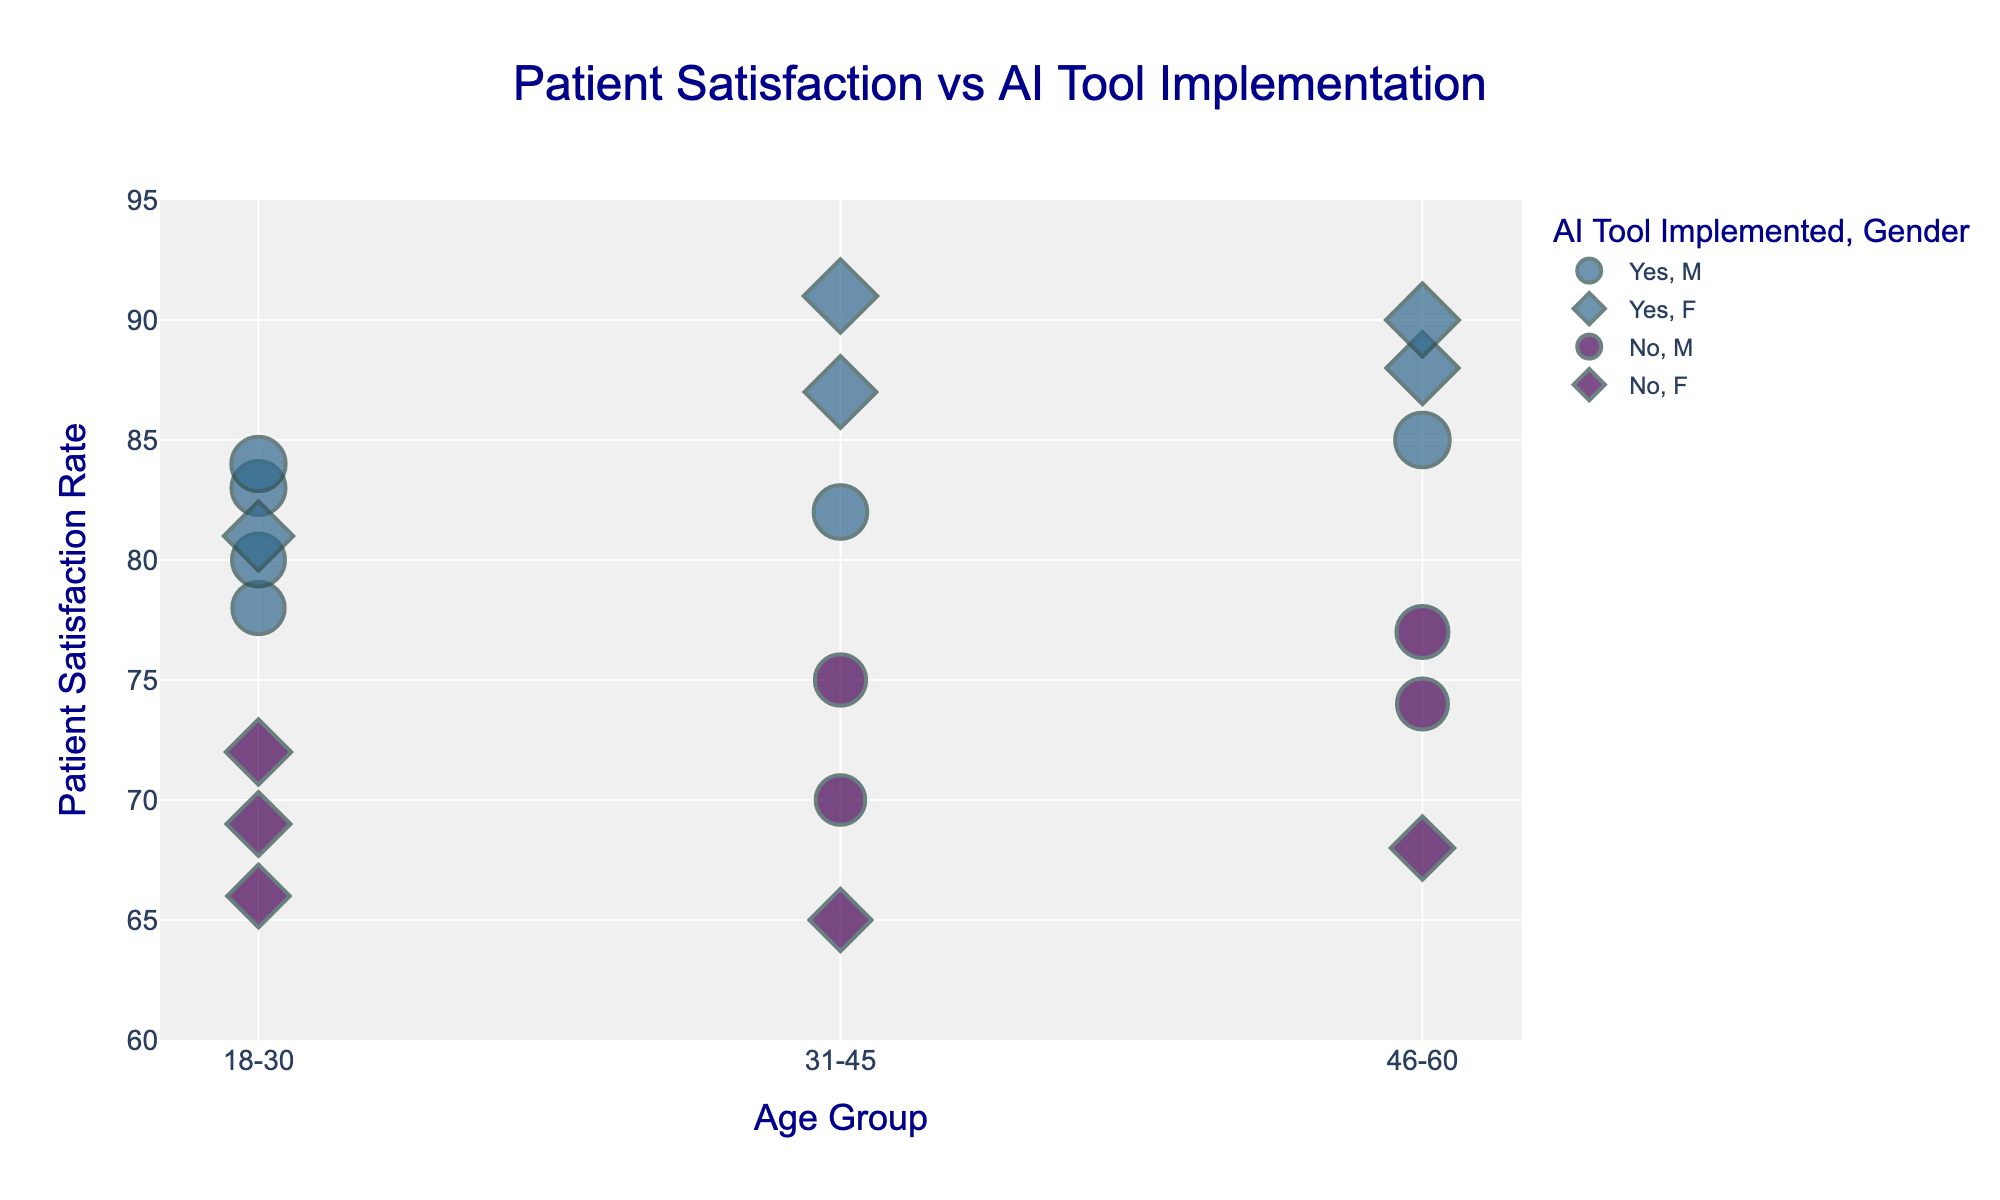What's the title of the scatter plot? The title is usually displayed at the top of the figure. In this plot, it should be easily noticeable.
Answer: Patient Satisfaction vs AI Tool Implementation What does the x-axis represent? The label for the x-axis is clearly mentioned.
Answer: Age Group Which color indicates that an AI tool is implemented? From the color legend, the color representing "Yes" can be identified.
Answer: Green (or colors[3]) How many age groups are represented in the scatter plot? Look at the unique values on the x-axis to count the age groups depicted.
Answer: Three (18-30, 31-45, 46-60) What's the highest patient satisfaction rate shown on the y-axis? Observe the y-axis range to find the highest value indicated there.
Answer: 91 In which age group is the highest patient satisfaction rate observed, and what demographic does it belong to? Locate the point with the highest value on the y-axis and inspect its corresponding x-axis value and hover information.
Answer: 31-45, Native American Which gender has a higher patient satisfaction rate in the 31-45 age group with AI tool implementation? Compare the symbols and points for males and females within the 31-45 age group where AI tools are implemented.
Answer: Female How does the average patient satisfaction rate compare between those with AI tools implemented and those without? Calculate the average patient satisfaction rate separately for points marked "Yes" and "No" in the AI Tool Implemented column.
Answer: AI yes: (78+81+82+88+80+85+83+87+90+84+91)/11 = 84.545; AI no: (65+74+69+75+68+70+77+66)/8 = 70.5 Which region has the highest average patient satisfaction rate for implemented AI tools? Filter the data points based on both region and AI tool implementation being "Yes" and then calculate the average for each region.
Answer: Midwest (Based on a single high value from Native American demographic) In the 46-60 age group, which demographic has the lowest patient satisfaction rate without AI tool implementation? Filter out the points where AI Tool Implemented is "No" for the 46-60 age group and identify the lowest y-axis value and the corresponding demographic.
Answer: African American 